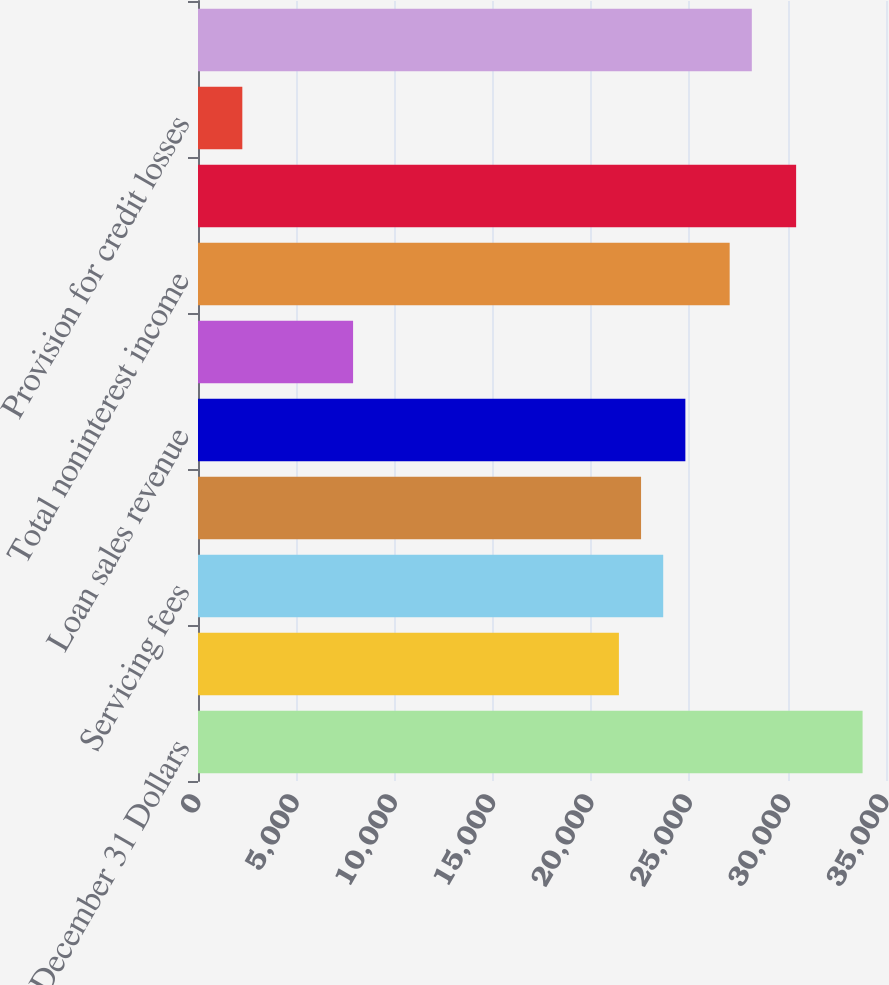Convert chart to OTSL. <chart><loc_0><loc_0><loc_500><loc_500><bar_chart><fcel>Year ended December 31 Dollars<fcel>Net interest income<fcel>Servicing fees<fcel>Net MSR hedging gains<fcel>Loan sales revenue<fcel>Other<fcel>Total noninterest income<fcel>Total revenue<fcel>Provision for credit losses<fcel>Noninterest expense<nl><fcel>33808.6<fcel>21412.4<fcel>23666.2<fcel>22539.3<fcel>24793.2<fcel>7889.21<fcel>27047<fcel>30427.8<fcel>2254.56<fcel>28174<nl></chart> 